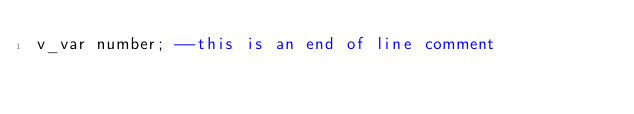Convert code to text. <code><loc_0><loc_0><loc_500><loc_500><_SQL_>v_var number; --this is an end of line comment
</code> 